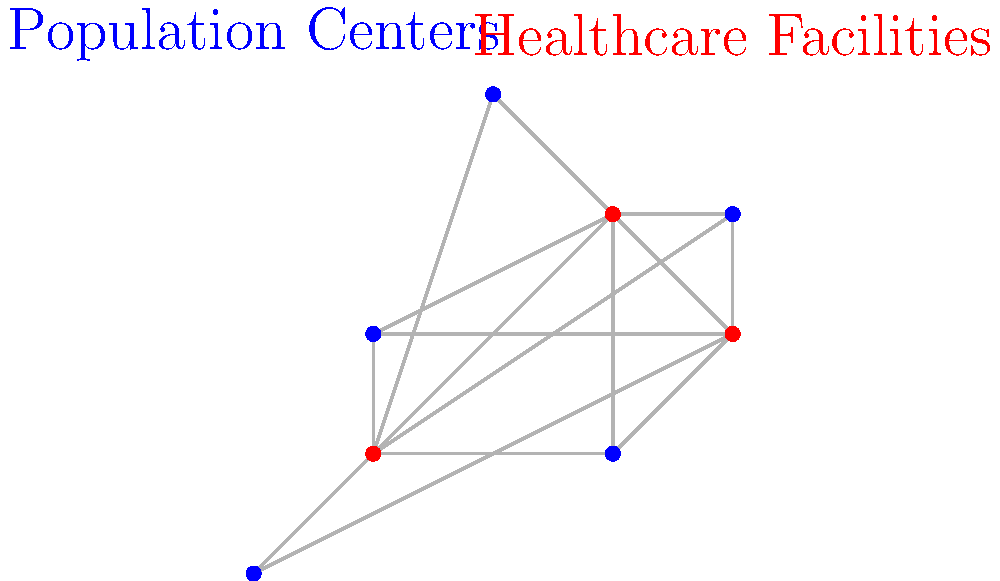In the network diagram above, blue dots represent population centers, and red dots represent healthcare facilities. What is the maximum number of population centers that can be uniquely assigned to the closest healthcare facility (i.e., no two population centers are assigned to the same facility)? To solve this problem, we need to follow these steps:

1. For each population center, determine the closest healthcare facility:
   - Population center at (0,0): Closest facility is at (1,1)
   - Population center at (1,2): Closest facility is at (1,1)
   - Population center at (3,1): Closest facility is at (3,3)
   - Population center at (4,3): Closest facility is at (3,3)
   - Population center at (2,4): Closest facility is at (3,3)

2. Assign each population center to its closest facility, ensuring no two centers are assigned to the same facility:
   - Assign (0,0) to facility at (1,1)
   - Assign (1,2) to facility at (1,1) - but this conflicts with (0,0), so we can't assign it
   - Assign (3,1) to facility at (3,3)
   - Assign (4,3) to facility at (4,2)
   - Assign (2,4) to facility at (3,3) - but this conflicts with (3,1), so we can't assign it

3. Count the number of unique assignments:
   - (0,0) to (1,1)
   - (3,1) to (3,3)
   - (4,3) to (4,2)

Therefore, the maximum number of population centers that can be uniquely assigned to the closest healthcare facility is 3.
Answer: 3 